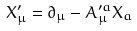Convert formula to latex. <formula><loc_0><loc_0><loc_500><loc_500>X _ { \mu } ^ { \prime } = \partial _ { \mu } - A _ { \mu } ^ { \prime a } X _ { a }</formula> 